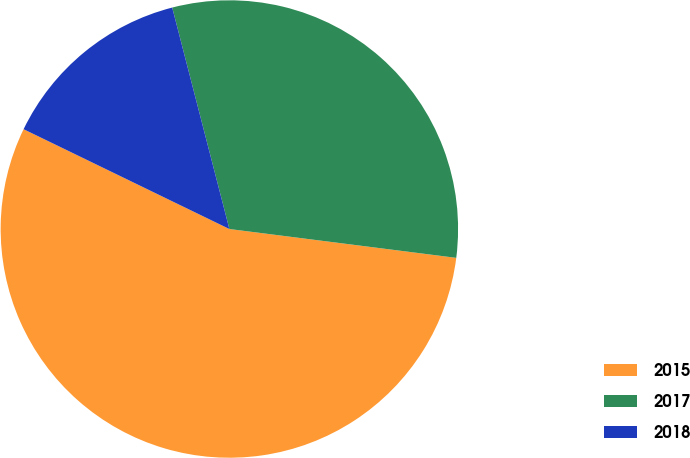Convert chart to OTSL. <chart><loc_0><loc_0><loc_500><loc_500><pie_chart><fcel>2015<fcel>2017<fcel>2018<nl><fcel>55.17%<fcel>31.03%<fcel>13.79%<nl></chart> 